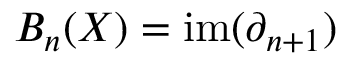<formula> <loc_0><loc_0><loc_500><loc_500>B _ { n } ( X ) = i m ( \partial _ { n + 1 } )</formula> 